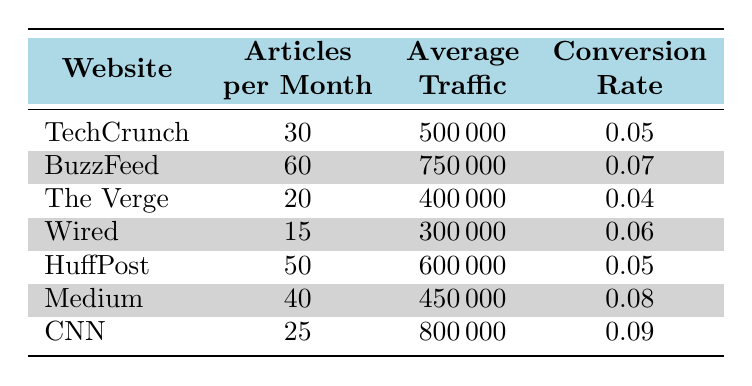What is the publication frequency (articles per month) of BuzzFeed? From the table, BuzzFeed has a row that states its articles per month. Looking directly at that row provides the specific figure.
Answer: 60 Which website has the highest average traffic? By scanning the average traffic column, we locate the website with the maximum value. CNN shows the highest figure of 800,000.
Answer: CNN Is the conversion rate of Wired greater than 0.05? The conversion rate for Wired can be found in its row, where it is noted as 0.06. Since 0.06 is greater than 0.05, the answer is yes.
Answer: Yes What is the total number of articles published per month across all websites? To find the total, we sum the articles per month for all websites: 30 + 60 + 20 + 15 + 50 + 40 + 25 = 250. Thus, the total number of articles is 250.
Answer: 250 What is the average conversion rate of the websites listed? To calculate the average conversion rate, we first sum all the conversion rates: 0.05 + 0.07 + 0.04 + 0.06 + 0.05 + 0.08 + 0.09 = 0.44. Since there are 7 websites, we divide 0.44 by 7, which gives 0.062857. Rounding gives an average of approximately 0.063.
Answer: 0.063 Is the average traffic for Medium higher than that for The Verge? We check the average traffic values for both Medium (450,000) and The Verge (400,000). Since 450,000 is greater than 400,000, we conclude that Medium does indeed have higher traffic.
Answer: Yes Which website has the lowest conversion rate? Reviewing the conversion rate column, we identify that The Verge has the lowest figure at 0.04, making it the website with the lowest conversion rate.
Answer: The Verge What is the difference in average traffic between CNN and Wired? To find the difference, we subtract Wired's average traffic (300,000) from CNN's (800,000), yielding a difference of 500,000.
Answer: 500000 How many websites have a conversion rate greater than 0.06? We examine the conversion rates, which are 0.05, 0.07, 0.04, 0.06, 0.05, 0.08, 0.09. The rates that are greater than 0.06 are 0.07, 0.08, and 0.09, which accounts for 3 websites.
Answer: 3 Is the average number of articles per month for sites with a conversion rate less than 0.06 above 30? First, identify the websites with a conversion rate less than 0.06: TechCrunch (0.05), The Verge (0.04), and HuffPost (0.05). Their article counts are 30, 20, and 50 respectively. The average is calculated as (30 + 20 + 50) / 3 = 100 / 3 = 33.33. Since 33.33 is greater than 30, the answer is yes.
Answer: Yes 